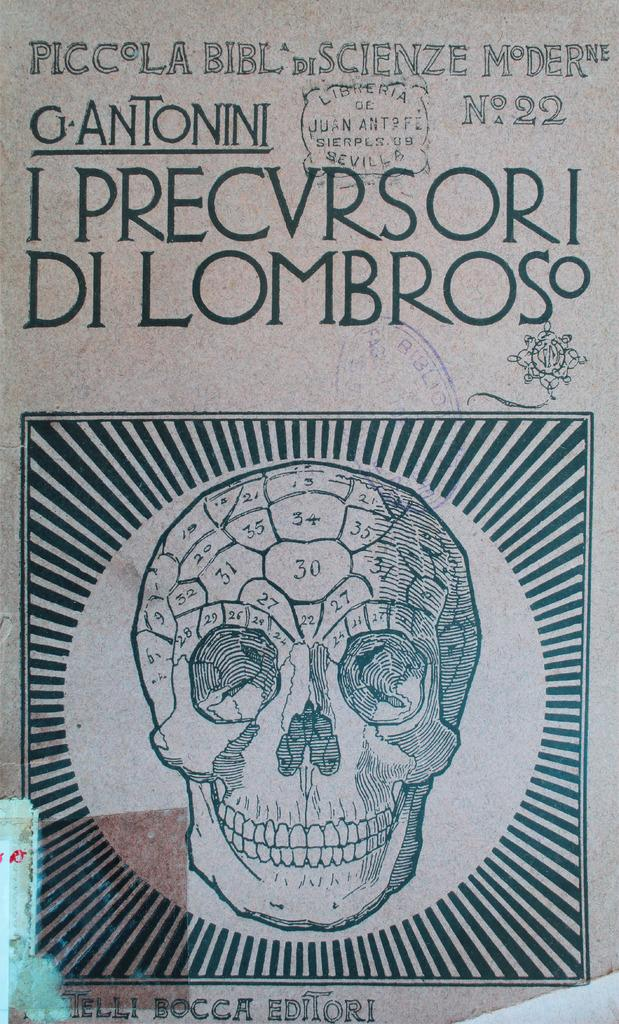<image>
Summarize the visual content of the image. Piccola Bibl di scienze moderne gantonni I precvrsori Di Lombroso 